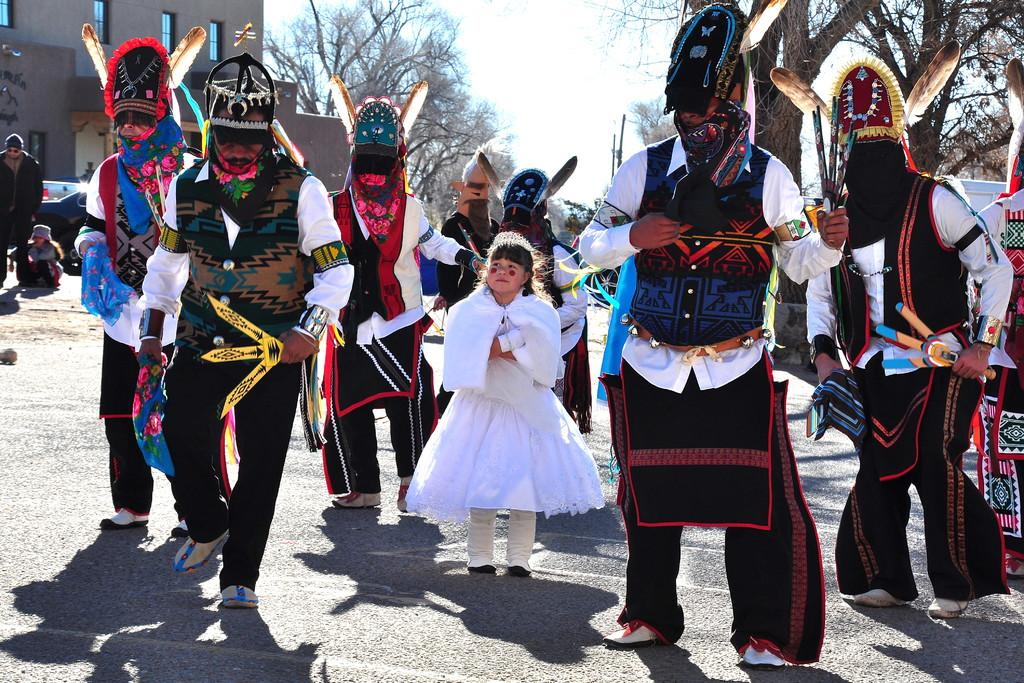What are the persons in the image wearing? The persons in the image are wearing costumes. Where are the persons in the image? The persons are standing on the ground. What can be seen in the background of the image? There are vehicles, buildings, trees, and the sky visible in the background of the image. What type of apparatus is being used by the persons in the image? There is no apparatus visible in the image; the persons are simply standing on the ground wearing costumes. What company is responsible for the vehicles in the background of the image? The image does not provide information about the company responsible for the vehicles in the background. 